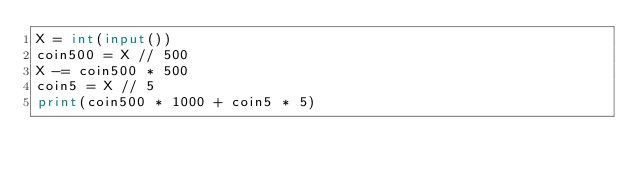Convert code to text. <code><loc_0><loc_0><loc_500><loc_500><_Python_>X = int(input())
coin500 = X // 500
X -= coin500 * 500
coin5 = X // 5
print(coin500 * 1000 + coin5 * 5)
</code> 